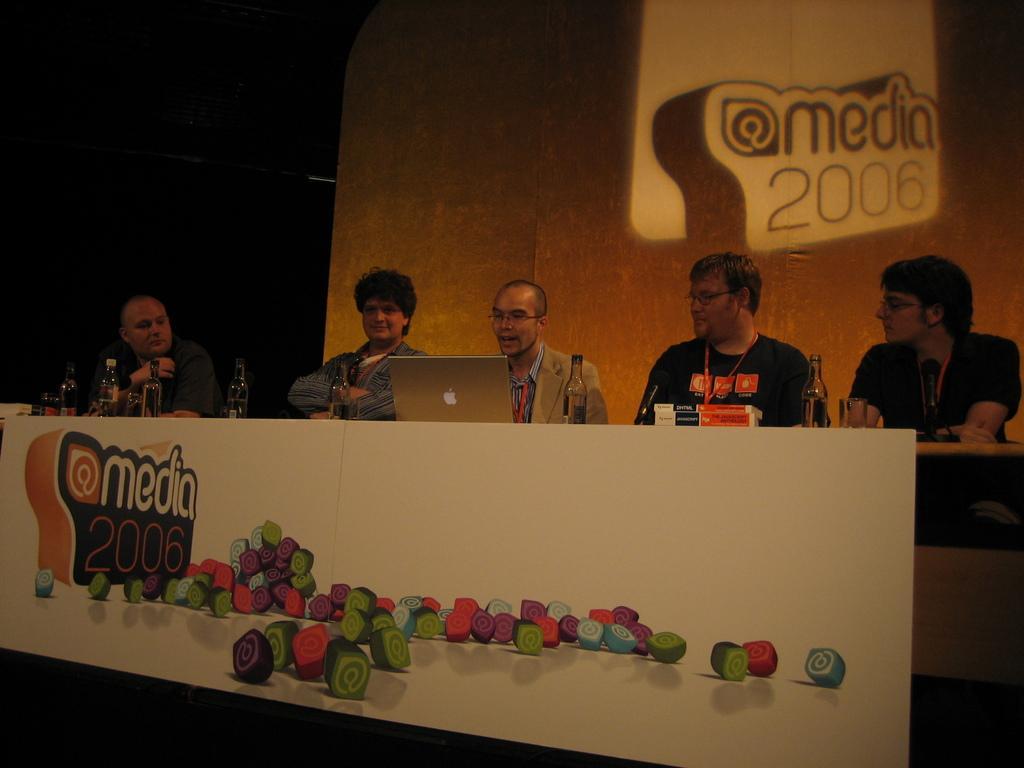Can you describe this image briefly? In this image, there are a few people. We can see a table with some objects like a laptop, bottles and books. We can also see a board with some images and text. In the background, we can see the screen. 